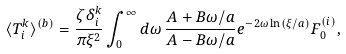<formula> <loc_0><loc_0><loc_500><loc_500>\langle T _ { i } ^ { k } \rangle ^ { ( b ) } = \frac { \zeta \delta _ { i } ^ { k } } { \pi \xi ^ { 2 } } \int _ { 0 } ^ { \infty } d \omega \, \frac { A + B \omega / a } { A - B \omega / a } e ^ { - 2 \omega \ln ( \xi / a ) } F _ { 0 } ^ { ( i ) } ,</formula> 